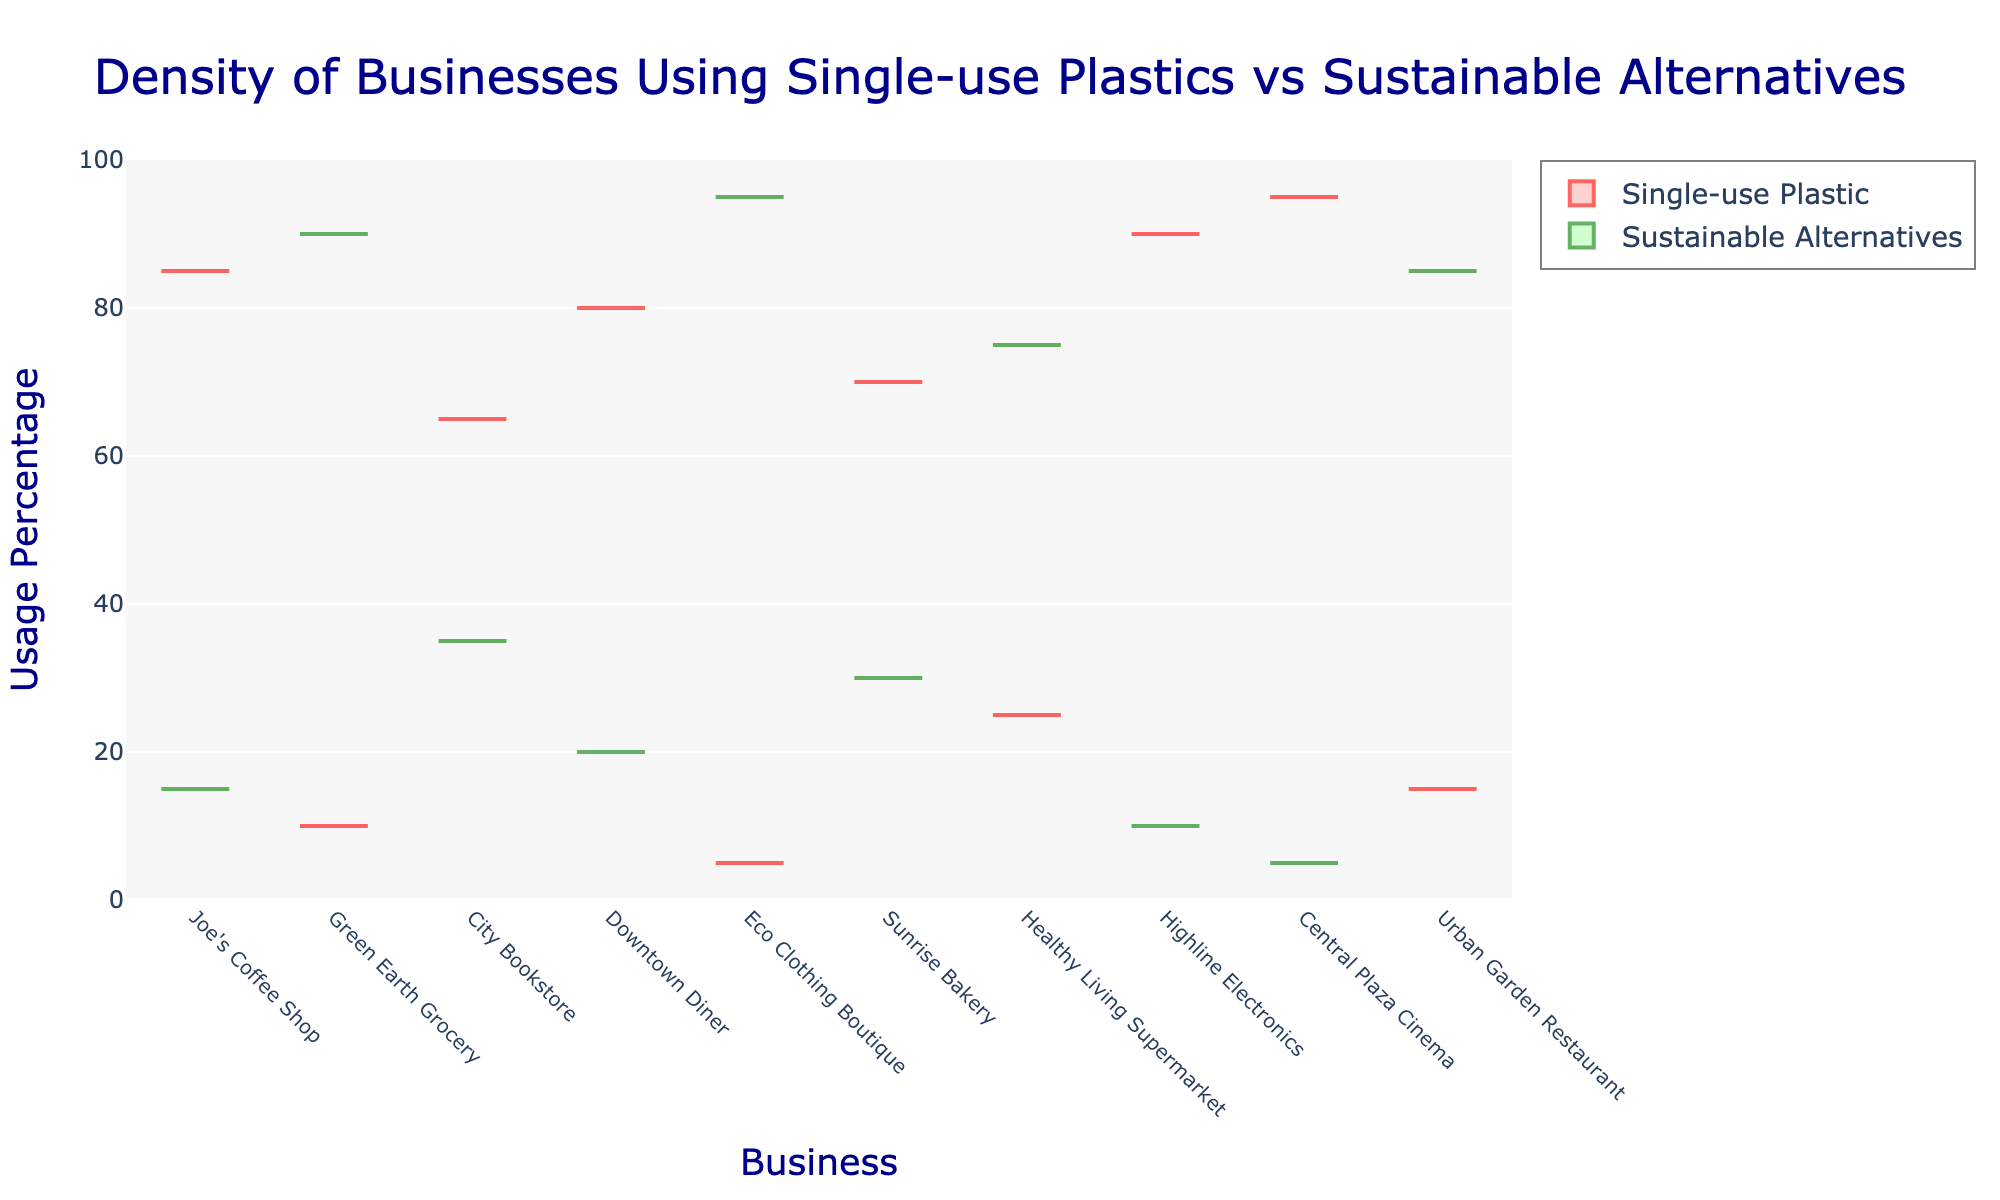What is the title of the figure? The title is prominently displayed at the top center of the plot in large font size.
Answer: Density of Businesses Using Single-use Plastics vs Sustainable Alternatives What is the range of the y-axis? The y-axis range is displayed on the left side of the plot, spanning from 0 to 100.
Answer: 0 to 100 Which business uses the highest percentage of single-use plastics? The violin plot indicates that "Central Plaza Cinema" has the highest density point for single-use plastics at 95%.
Answer: Central Plaza Cinema How many businesses are there in the dataset? The x-axis lists each business name. By counting them, we see there are 10 business names.
Answer: 10 Which business uses the lowest percentage of single-use plastics? The violin plot indicates that "Eco Clothing Boutique" has the lowest density point for single-use plastics at 5%.
Answer: Eco Clothing Boutique How do the usage of single-use plastics and sustainable alternatives compare for "Joe's Coffee Shop"? Joe's Coffee Shop uses 85% single-use plastics and 15% sustainable alternatives, as indicated by the respective violin plots.
Answer: 85% single-use plastics and 15% sustainable alternatives What is the average usage of sustainable alternatives across all businesses? Add up the percentage usage of sustainable alternatives for all businesses and divide by the number of businesses (15 + 90 + 35 + 20 + 95 + 30 + 75 + 10 + 5 + 85). The total is 460. Dividing by 10 businesses gives an average of 46%.
Answer: 46% Which type of usage has a higher median value—single-use plastics or sustainable alternatives? By analyzing the distribution of the violin plots, we can observe that the median of sustainable alternatives appears visually lower than single-use plastics. However, detailed inspection of the figure indicates the single-use plastics has higher median usage.
Answer: Single-use plastics How does the use of sustainable alternatives at "Green Earth Grocery" compare to "Urban Garden Restaurant"? The violin plot shows that Green Earth Grocery uses 90% sustainable alternatives while Urban Garden Restaurant uses 85%.
Answer: Green Earth Grocery uses 5% more sustainable alternatives than Urban Garden Restaurant Which business has nearly equal usage of single-use plastics and sustainable alternatives? By comparing the two violin plots, "City Bookstore" comes closest to an equal split, using 65% single-use plastics and 35% sustainable alternatives.
Answer: City Bookstore 